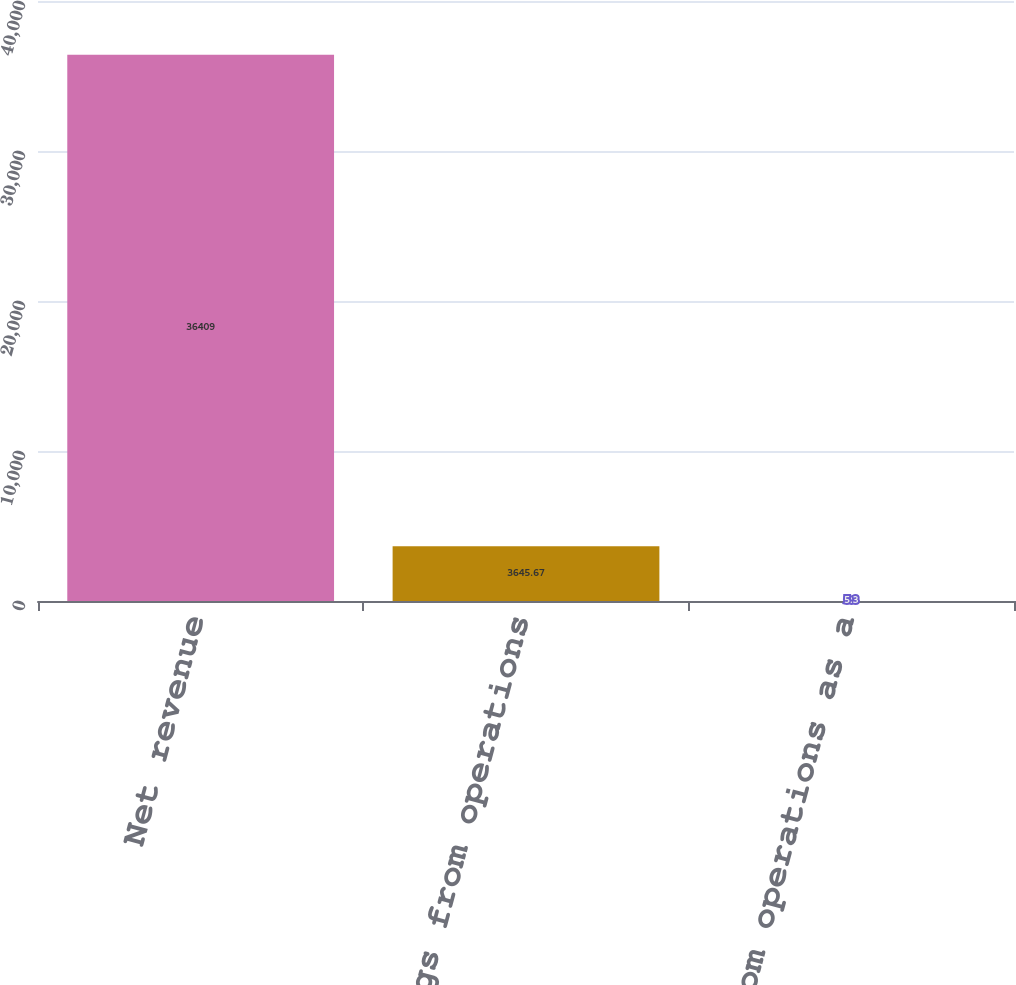<chart> <loc_0><loc_0><loc_500><loc_500><bar_chart><fcel>Net revenue<fcel>Earnings from operations<fcel>Earnings from operations as a<nl><fcel>36409<fcel>3645.67<fcel>5.3<nl></chart> 